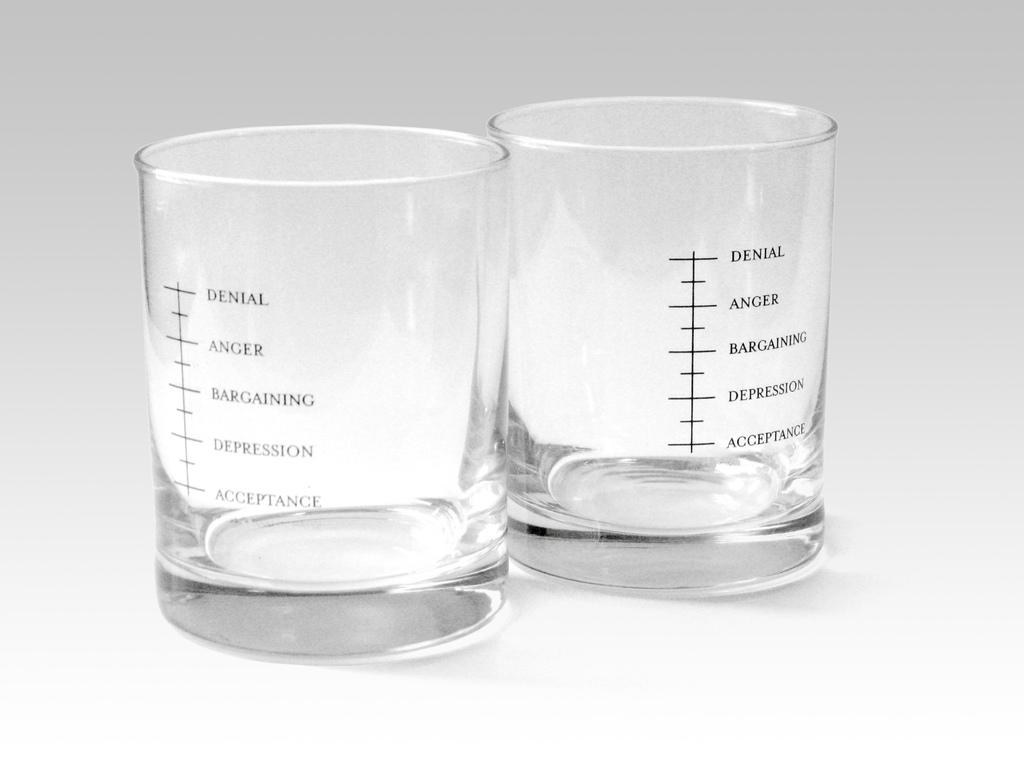<image>
Write a terse but informative summary of the picture. measuring cups with denial anger and barganing are shown 